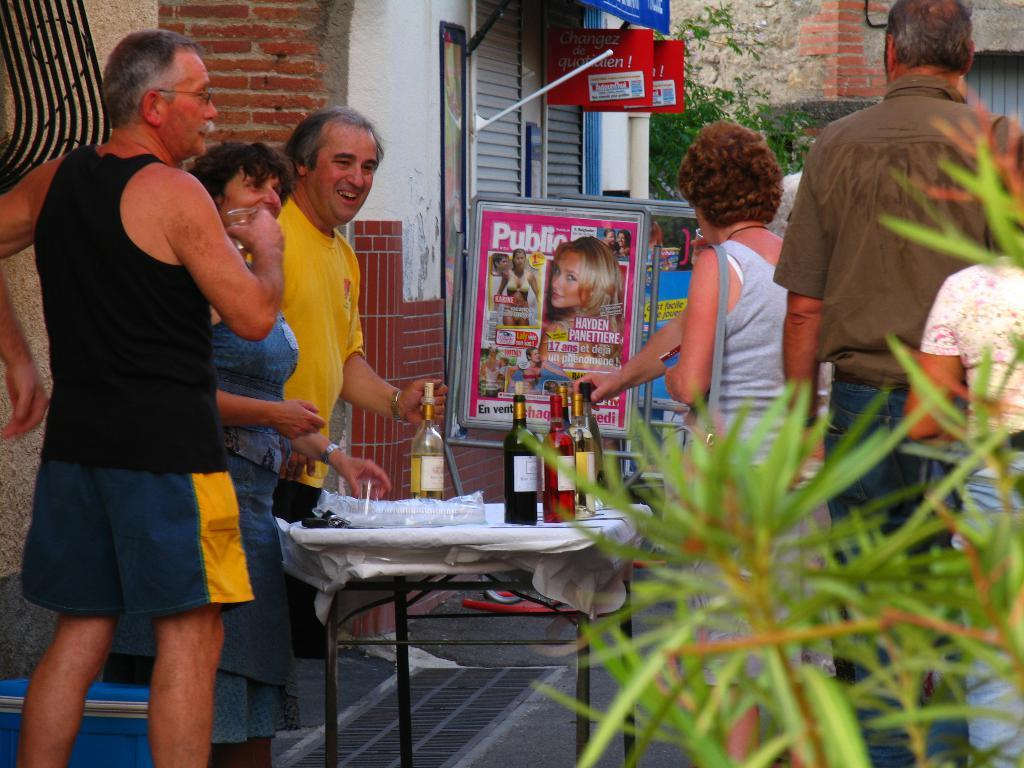<image>
Describe the image concisely. A poster in an outdoor space has information about Hayden Panettiere. 